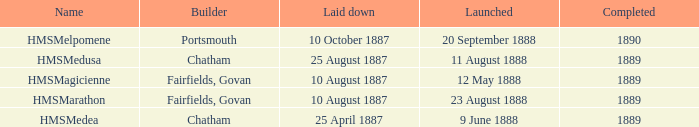What is the name of the boat that was built by Chatham and Laid down of 25 april 1887? HMSMedea. 